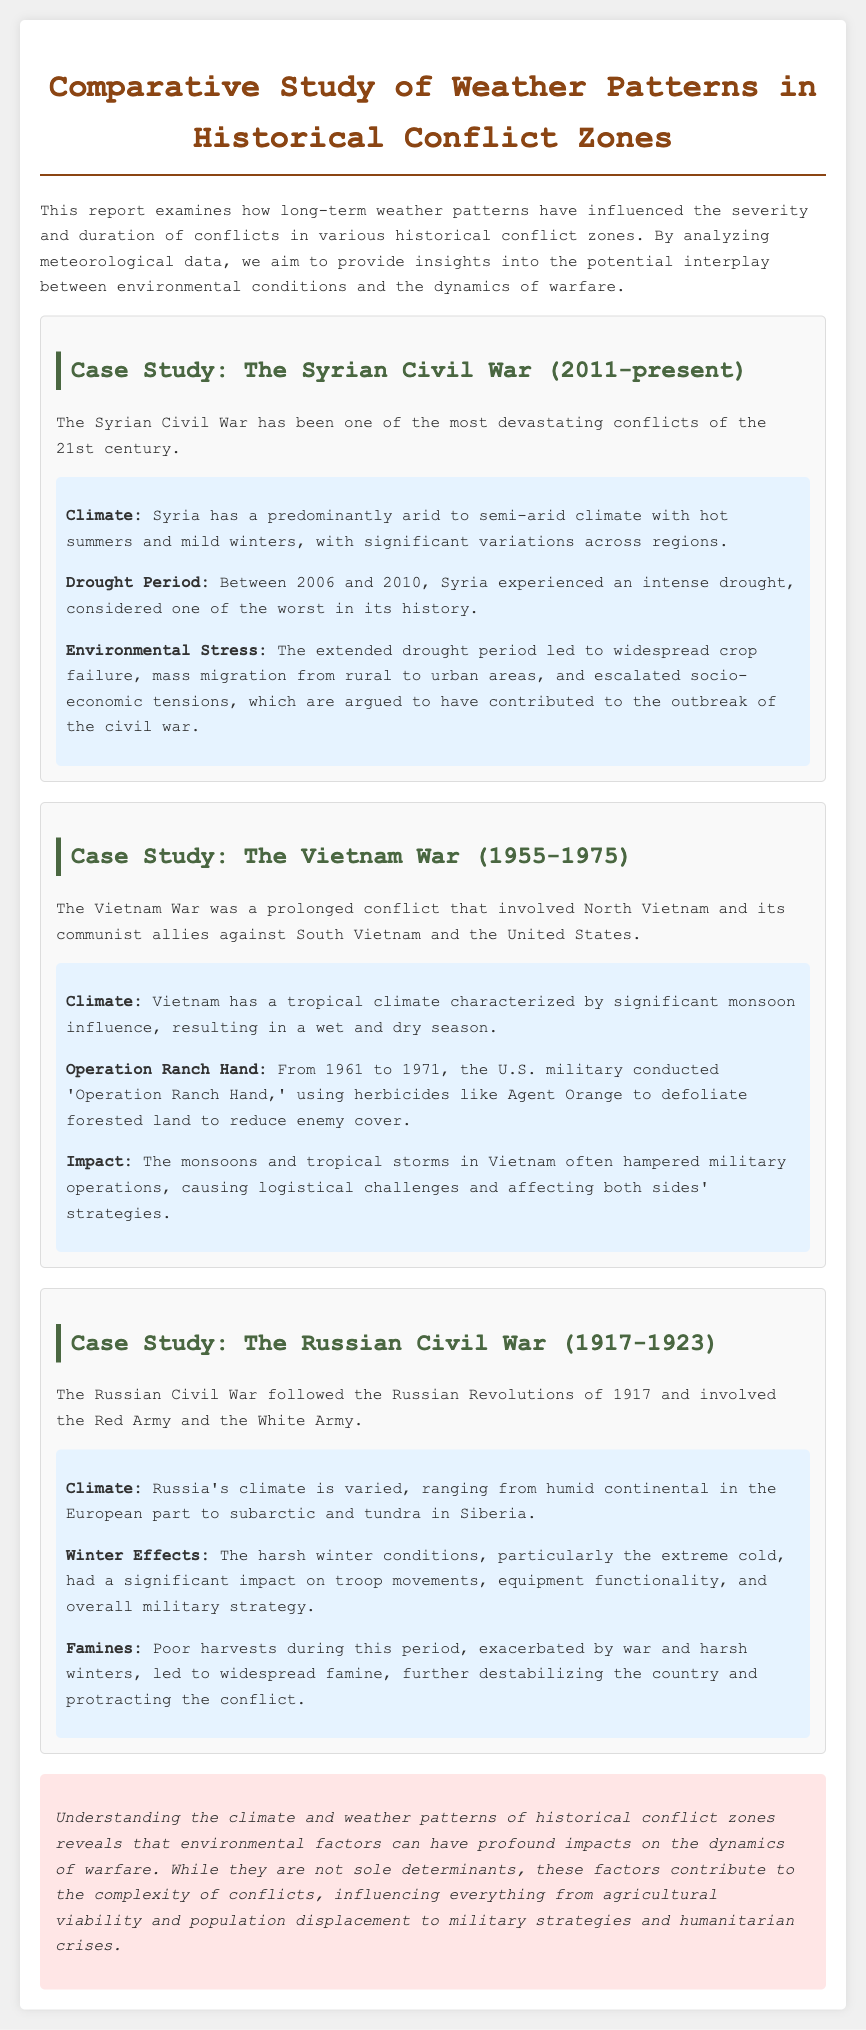what is the title of the report? The title of the report is found in the heading at the top of the document.
Answer: Comparative Study of Weather Patterns in Historical Conflict Zones what year did the Syrian Civil War start? The start year of the Syrian Civil War is mentioned in the case study description.
Answer: 2011 what climate type is predominant in Syria? The climate type for Syria is described in the weather data section of the Syrian Civil War case study.
Answer: Arid to semi-arid what operation involved the use of herbicides in Vietnam? This operation is referenced in the case study of the Vietnam War.
Answer: Operation Ranch Hand how many years did the Vietnam War last? The duration of the Vietnam War can be calculated from the years stated in the case study.
Answer: 20 years what significant weather condition affected troop movements during the Russian Civil War? This condition is noted in the weather data section related to the Russian Civil War case study.
Answer: Extreme cold what was a major consequence of the drought in Syria? The drought's impact on Syria is elaborated in the corresponding case study.
Answer: Crop failure how did monsoons affect military operations in Vietnam? The effect of monsoons on military strategy is discussed in the weather data for the Vietnam War.
Answer: Hampered operations what does the conclusion suggest about environmental factors in conflicts? The conclusion summarizes insights into the role of environmental conditions in conflicts.
Answer: Profound impacts 